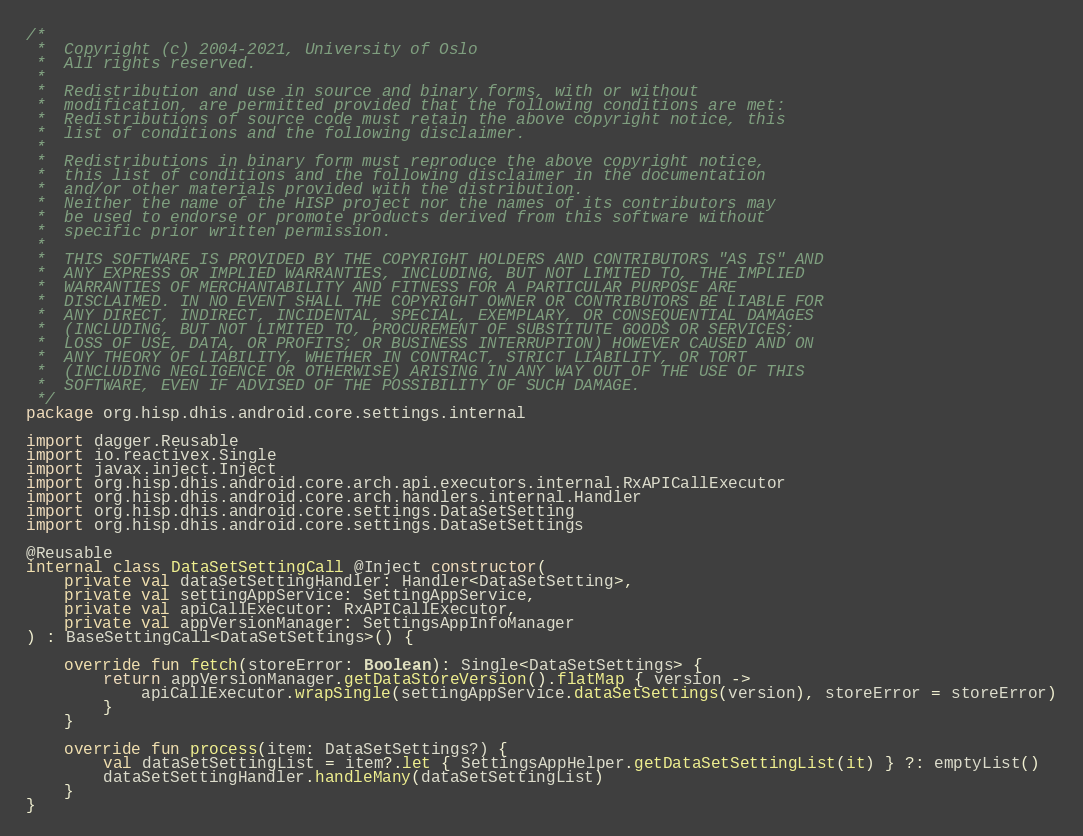Convert code to text. <code><loc_0><loc_0><loc_500><loc_500><_Kotlin_>/*
 *  Copyright (c) 2004-2021, University of Oslo
 *  All rights reserved.
 *
 *  Redistribution and use in source and binary forms, with or without
 *  modification, are permitted provided that the following conditions are met:
 *  Redistributions of source code must retain the above copyright notice, this
 *  list of conditions and the following disclaimer.
 *
 *  Redistributions in binary form must reproduce the above copyright notice,
 *  this list of conditions and the following disclaimer in the documentation
 *  and/or other materials provided with the distribution.
 *  Neither the name of the HISP project nor the names of its contributors may
 *  be used to endorse or promote products derived from this software without
 *  specific prior written permission.
 *
 *  THIS SOFTWARE IS PROVIDED BY THE COPYRIGHT HOLDERS AND CONTRIBUTORS "AS IS" AND
 *  ANY EXPRESS OR IMPLIED WARRANTIES, INCLUDING, BUT NOT LIMITED TO, THE IMPLIED
 *  WARRANTIES OF MERCHANTABILITY AND FITNESS FOR A PARTICULAR PURPOSE ARE
 *  DISCLAIMED. IN NO EVENT SHALL THE COPYRIGHT OWNER OR CONTRIBUTORS BE LIABLE FOR
 *  ANY DIRECT, INDIRECT, INCIDENTAL, SPECIAL, EXEMPLARY, OR CONSEQUENTIAL DAMAGES
 *  (INCLUDING, BUT NOT LIMITED TO, PROCUREMENT OF SUBSTITUTE GOODS OR SERVICES;
 *  LOSS OF USE, DATA, OR PROFITS; OR BUSINESS INTERRUPTION) HOWEVER CAUSED AND ON
 *  ANY THEORY OF LIABILITY, WHETHER IN CONTRACT, STRICT LIABILITY, OR TORT
 *  (INCLUDING NEGLIGENCE OR OTHERWISE) ARISING IN ANY WAY OUT OF THE USE OF THIS
 *  SOFTWARE, EVEN IF ADVISED OF THE POSSIBILITY OF SUCH DAMAGE.
 */
package org.hisp.dhis.android.core.settings.internal

import dagger.Reusable
import io.reactivex.Single
import javax.inject.Inject
import org.hisp.dhis.android.core.arch.api.executors.internal.RxAPICallExecutor
import org.hisp.dhis.android.core.arch.handlers.internal.Handler
import org.hisp.dhis.android.core.settings.DataSetSetting
import org.hisp.dhis.android.core.settings.DataSetSettings

@Reusable
internal class DataSetSettingCall @Inject constructor(
    private val dataSetSettingHandler: Handler<DataSetSetting>,
    private val settingAppService: SettingAppService,
    private val apiCallExecutor: RxAPICallExecutor,
    private val appVersionManager: SettingsAppInfoManager
) : BaseSettingCall<DataSetSettings>() {

    override fun fetch(storeError: Boolean): Single<DataSetSettings> {
        return appVersionManager.getDataStoreVersion().flatMap { version ->
            apiCallExecutor.wrapSingle(settingAppService.dataSetSettings(version), storeError = storeError)
        }
    }

    override fun process(item: DataSetSettings?) {
        val dataSetSettingList = item?.let { SettingsAppHelper.getDataSetSettingList(it) } ?: emptyList()
        dataSetSettingHandler.handleMany(dataSetSettingList)
    }
}
</code> 